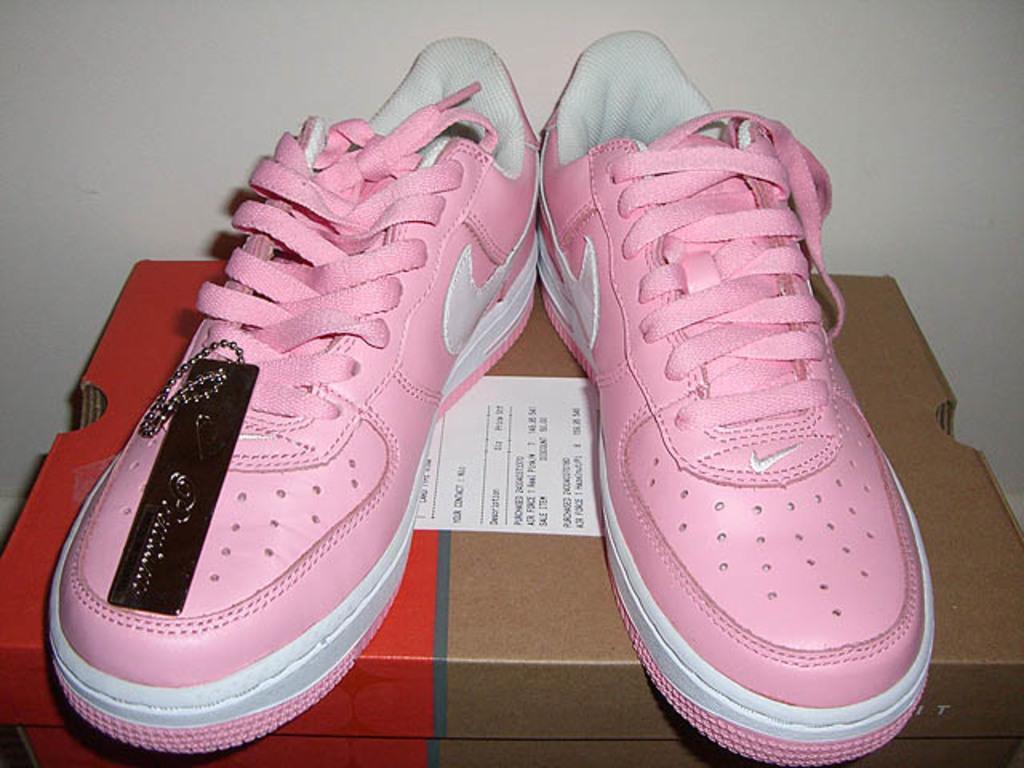Please provide a concise description of this image. In this picture I can see a box in front and I can see a sticker and I see something written on it and on the box I can see a pair of shoes, which are of white and pink color. In the background I can see the wall. 